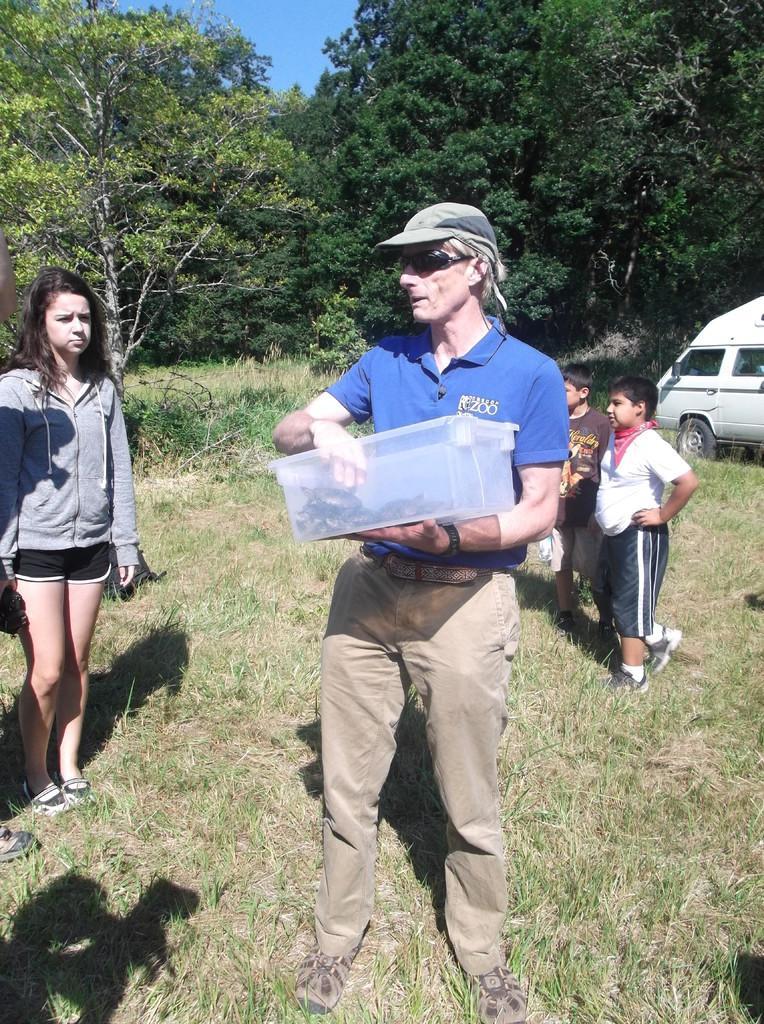Can you describe this image briefly? In the picture we can see a grass surface on it, we can see a man standing and holding a box with some reptiles in it and beside him we can see a woman and behind him we can see two children are standing and in the background we can see a van which is white in color and full of trees, and a part of the sky. 